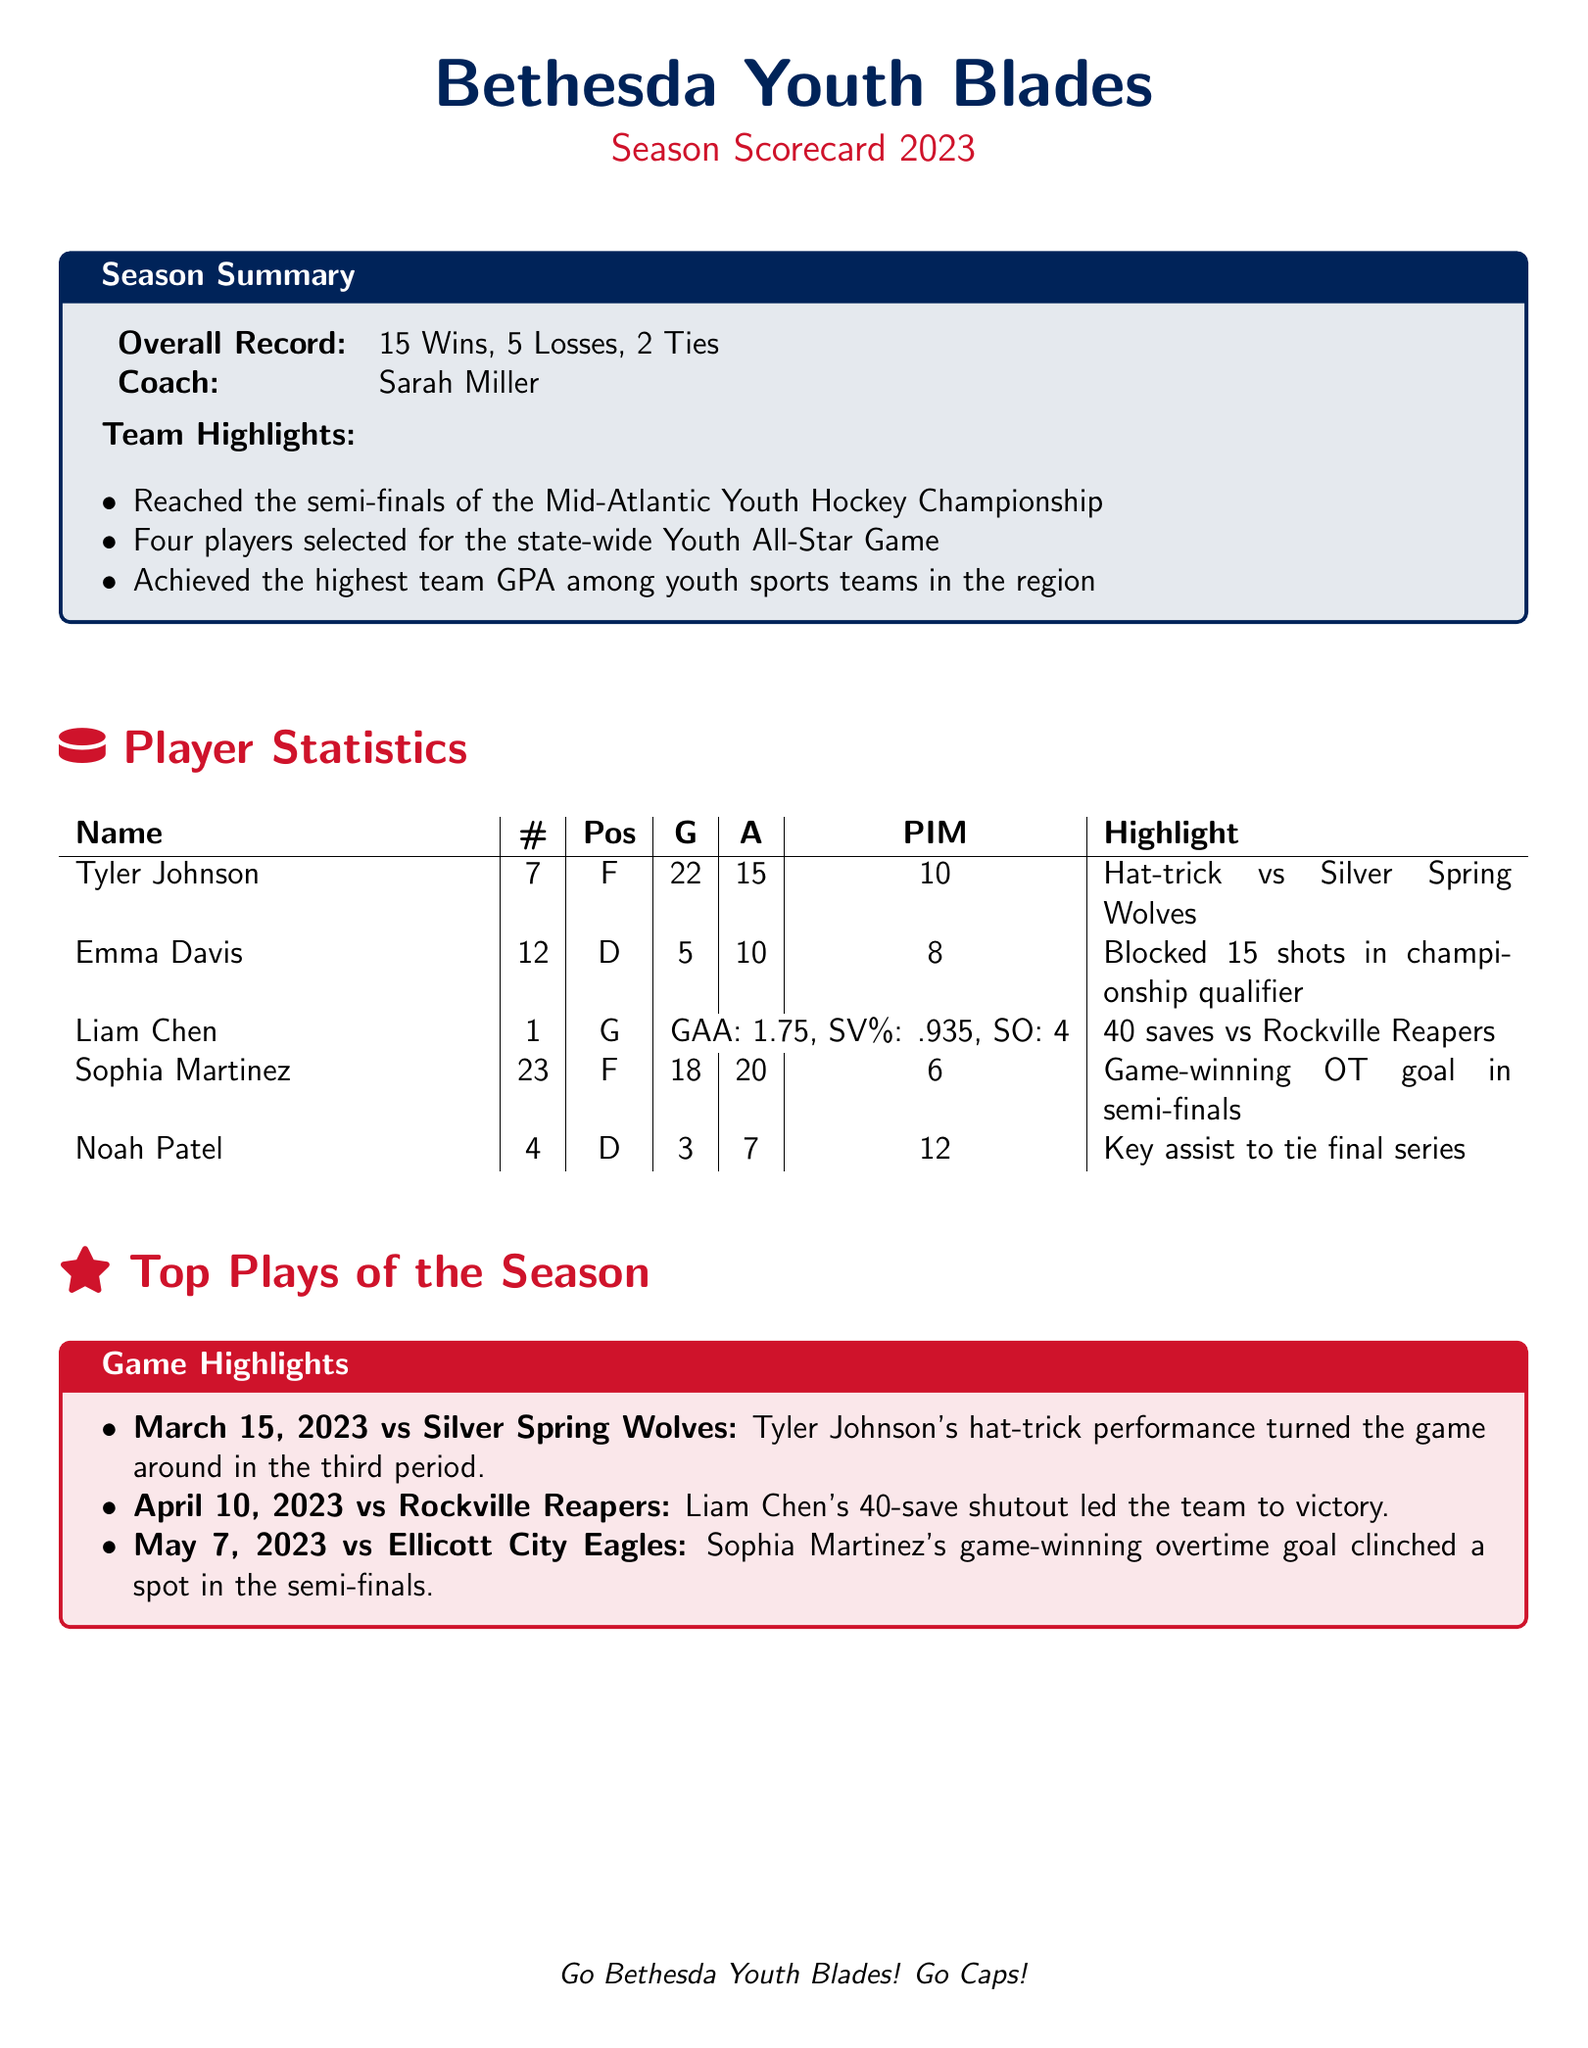What is the overall record of the team? The overall record is indicated in the season summary section of the document as 15 Wins, 5 Losses, 2 Ties.
Answer: 15 Wins, 5 Losses, 2 Ties Who is the coach of the Bethesda Youth Blades? The coach's name is mentioned in the season summary section.
Answer: Sarah Miller How many goals did Tyler Johnson score during the season? Tyler Johnson's total goals are recorded in the player statistics table.
Answer: 22 What was Liam Chen's save percentage? The save percentage for Liam Chen is listed under his statistics as .935.
Answer: .935 Which player had a highlight of blocking 15 shots? This highlight is associated with Emma Davis in the player statistics section.
Answer: Emma Davis What significant achievement did the team accomplish regarding academics? The document lists the achievement related to the team's GPA in the highlights section.
Answer: Highest team GPA among youth sports teams in the region How many players were selected for the Youth All-Star Game? The number of players selected is specified in the team highlights section.
Answer: Four players In which game did Sophia Martinez score a game-winning goal? This is detailed in the top plays of the season section, mentioning her specific game.
Answer: May 7, 2023 vs Ellicott City Eagles What was the Game-winning goal of Sophia Martinez? The document states her highlight information in the player statistics section.
Answer: Game-winning OT goal in semi-finals 